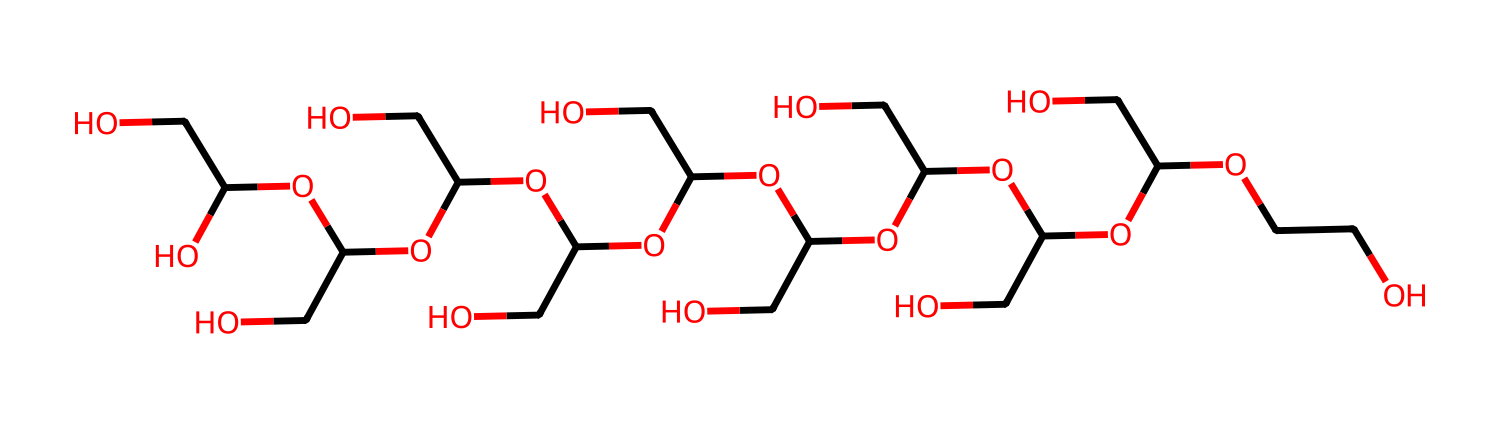How many carbon atoms are present in this molecule? The SMILES structure contains multiple 'C' characters that represent carbon atoms. By counting each occurrence, we identify there are 20 carbon atoms in total.
Answer: 20 What type of functional groups are evident in this compound? The SMILES representation shows several hydroxyl (–OH) groups as evident from the 'O' connected to 'C' and ending in 'O'. Each occurrence of 'O' attached to 'C' corresponds to a hydroxyl group, indicating the presence of multiple alcohol functional groups.
Answer: hydroxyl groups What is the primary structural feature that classifies this molecule as a Non-Newtonian fluid? The presence of a network of polymer chains allows this molecule to exhibit variable viscosity depending on the shear rate applied. This is characteristic of Non-Newtonian fluids, which change their flow behavior under stress rather than maintaining a constant viscosity.
Answer: polymer chains How many total oxygen atoms are present in this molecule? As represented in the SMILES, each 'O' indicates an oxygen atom. By counting the occurrences of 'O', we find that there are 10 oxygen atoms in total in the molecule.
Answer: 10 What is the likely effect of this molecular arrangement on the rheological properties of the cream? The repeated ether and hydroxyl functionalities lead to a network structure that can respond to shear forces, indicating that the cream will likely show both shear-thinning and thickening behaviors depending on the applied stress, which are typical for Non-Newtonian fluids.
Answer: shear-thinning and thickening What role does polyethylene glycol play when applied topically in creams? Polyethylene glycol (PEG) acts as a skin penetrant and moisture retainer, assisting in the delivery of other ingredients through the skin barrier, while also influencing the consistency and spreadability of the topical cream.
Answer: moisture retainer What is the primary molecular weight characteristic of polyethylene glycol in topical applications? Polyethylene glycol is often characterized by low to moderate molecular weight in topical formulations, typically ranging from around 200 to several thousand daltons, which contributes to its unique properties in creams.
Answer: low to moderate molecular weight 